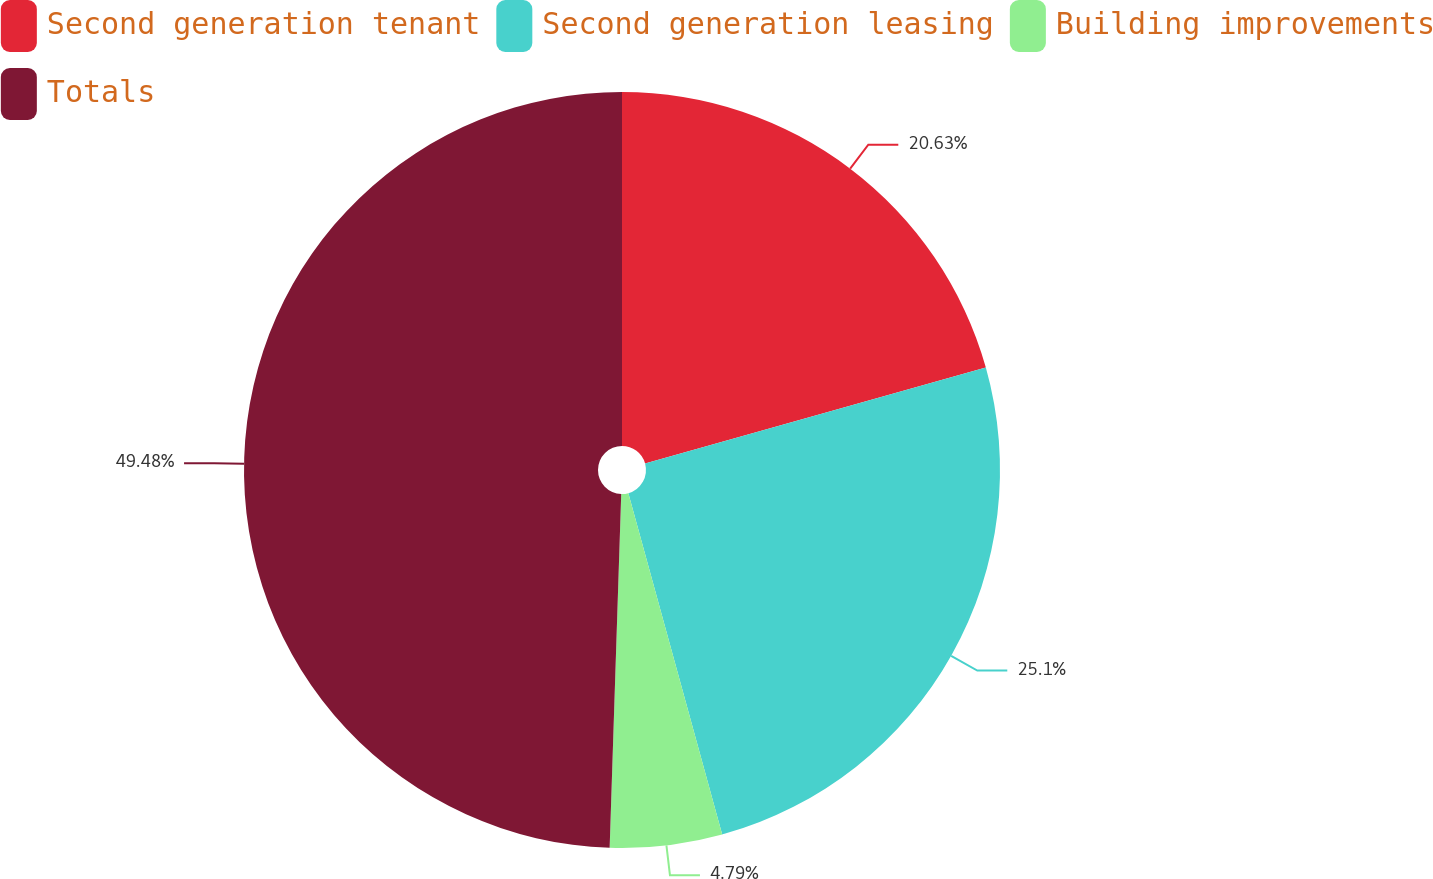Convert chart. <chart><loc_0><loc_0><loc_500><loc_500><pie_chart><fcel>Second generation tenant<fcel>Second generation leasing<fcel>Building improvements<fcel>Totals<nl><fcel>20.63%<fcel>25.1%<fcel>4.79%<fcel>49.48%<nl></chart> 